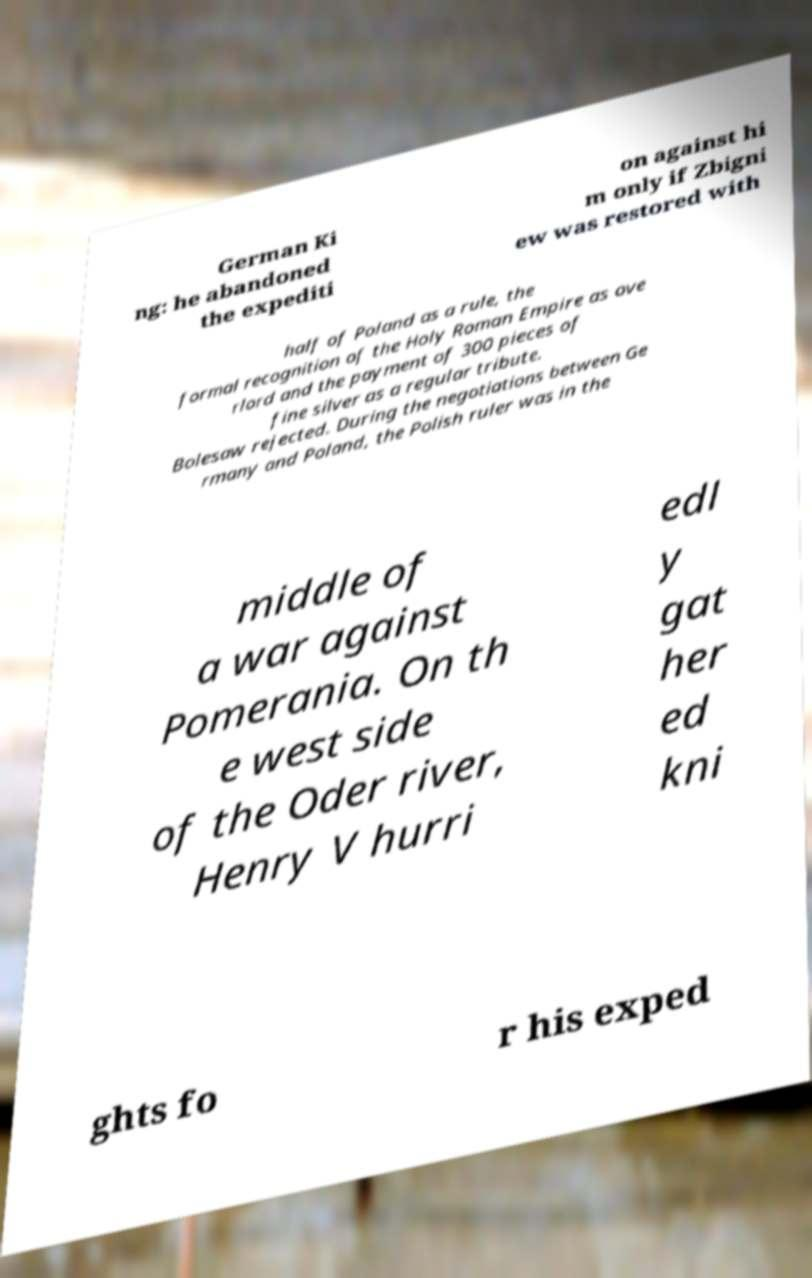What messages or text are displayed in this image? I need them in a readable, typed format. German Ki ng: he abandoned the expediti on against hi m only if Zbigni ew was restored with half of Poland as a rule, the formal recognition of the Holy Roman Empire as ove rlord and the payment of 300 pieces of fine silver as a regular tribute. Bolesaw rejected. During the negotiations between Ge rmany and Poland, the Polish ruler was in the middle of a war against Pomerania. On th e west side of the Oder river, Henry V hurri edl y gat her ed kni ghts fo r his exped 